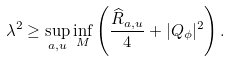Convert formula to latex. <formula><loc_0><loc_0><loc_500><loc_500>\lambda ^ { 2 } \geq \sup _ { a , u } \inf _ { M } \left ( \frac { \widehat { R } _ { a , u } } { 4 } + | Q _ { \phi } | ^ { 2 } \right ) .</formula> 